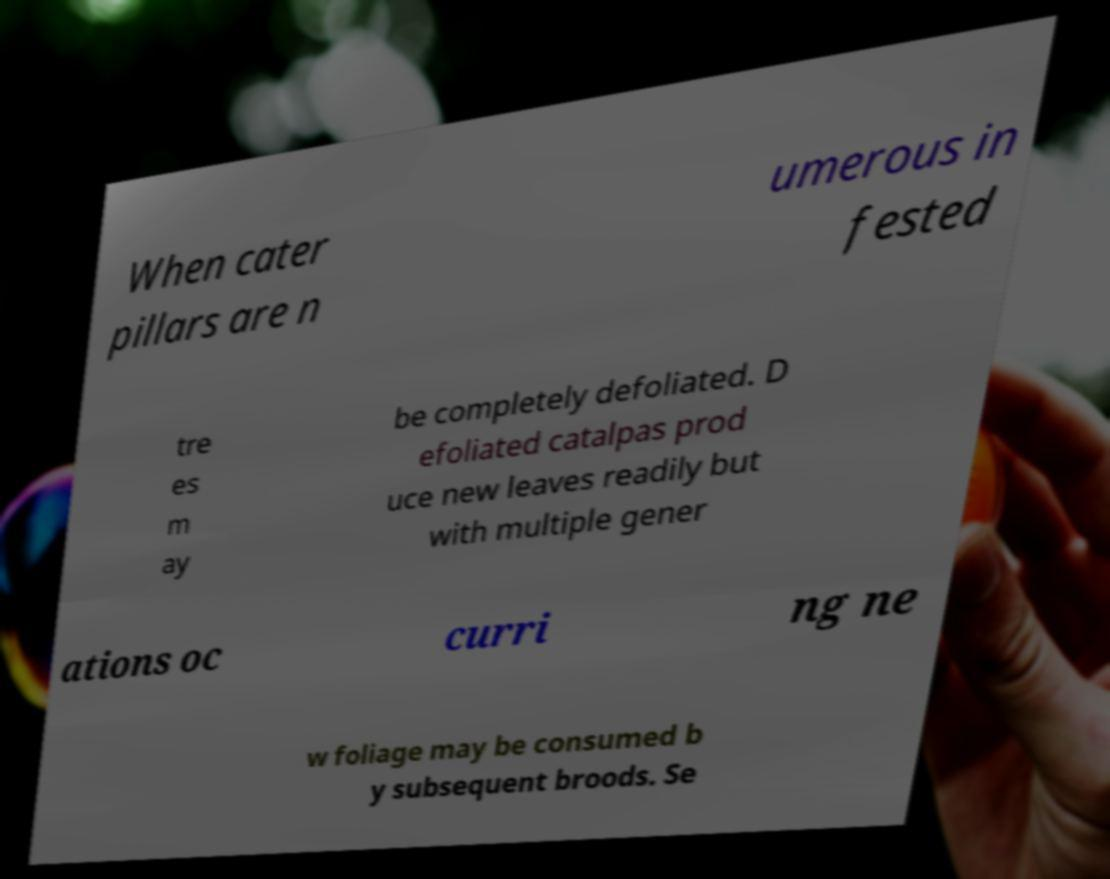Can you read and provide the text displayed in the image?This photo seems to have some interesting text. Can you extract and type it out for me? When cater pillars are n umerous in fested tre es m ay be completely defoliated. D efoliated catalpas prod uce new leaves readily but with multiple gener ations oc curri ng ne w foliage may be consumed b y subsequent broods. Se 